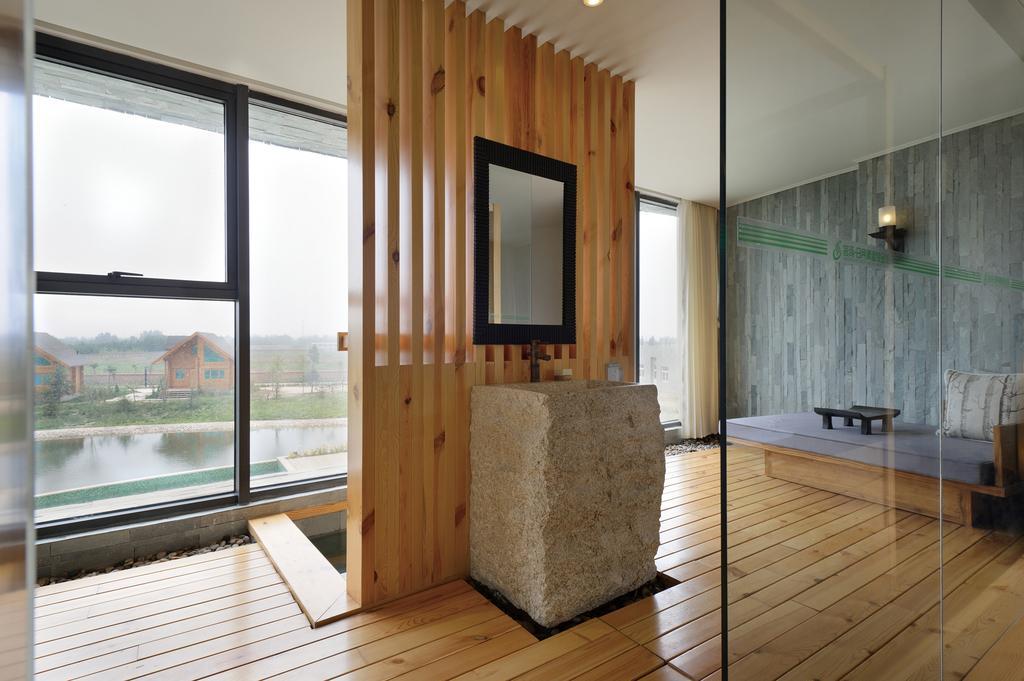Can you describe this image briefly? In this image we can see inside part of the house, there is a bed, pillow, mirror, windows, curtain, light, wooden floor, and a ceiling, there are some houses, plants, trees, water, also we can see the sky. 